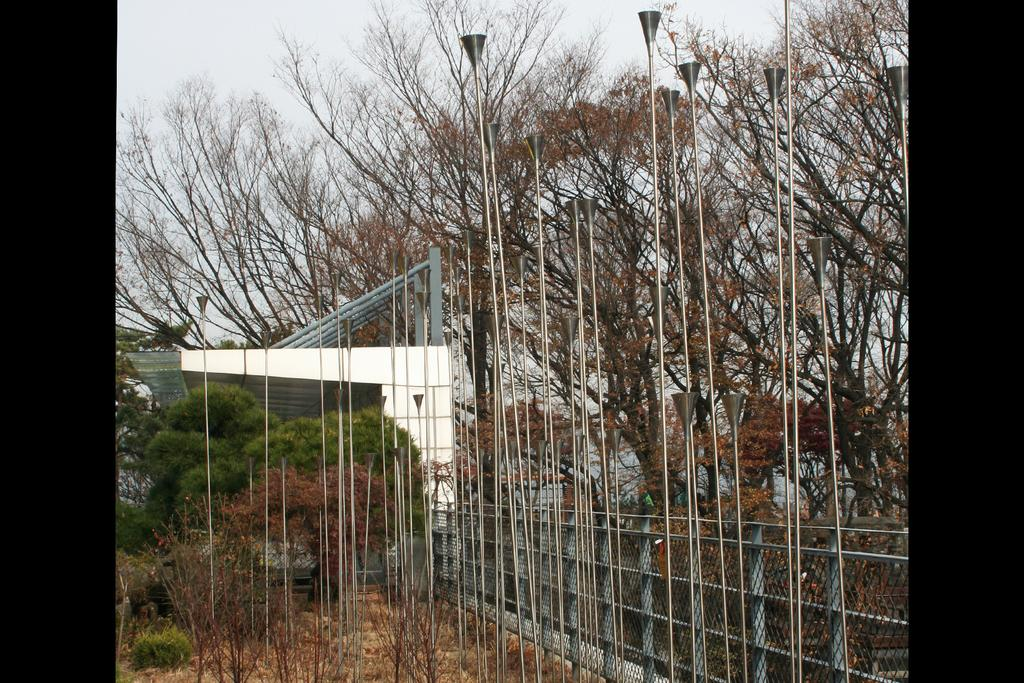What type of setting is depicted in the image? The image is an outside view. What structures can be seen in the image? There are poles and a building visible in the image. What type of vegetation is present in the image? There are trees in the image. What type of barrier can be seen in the image? There is net fencing in the image. What is visible at the top of the image? The sky is visible at the top of the image. What type of engine is powering the stick in the image? There is no stick or engine present in the image. How many ants can be seen crawling on the building in the image? There are no ants visible in the image; it only features poles, a building, trees, net fencing, and the sky. 